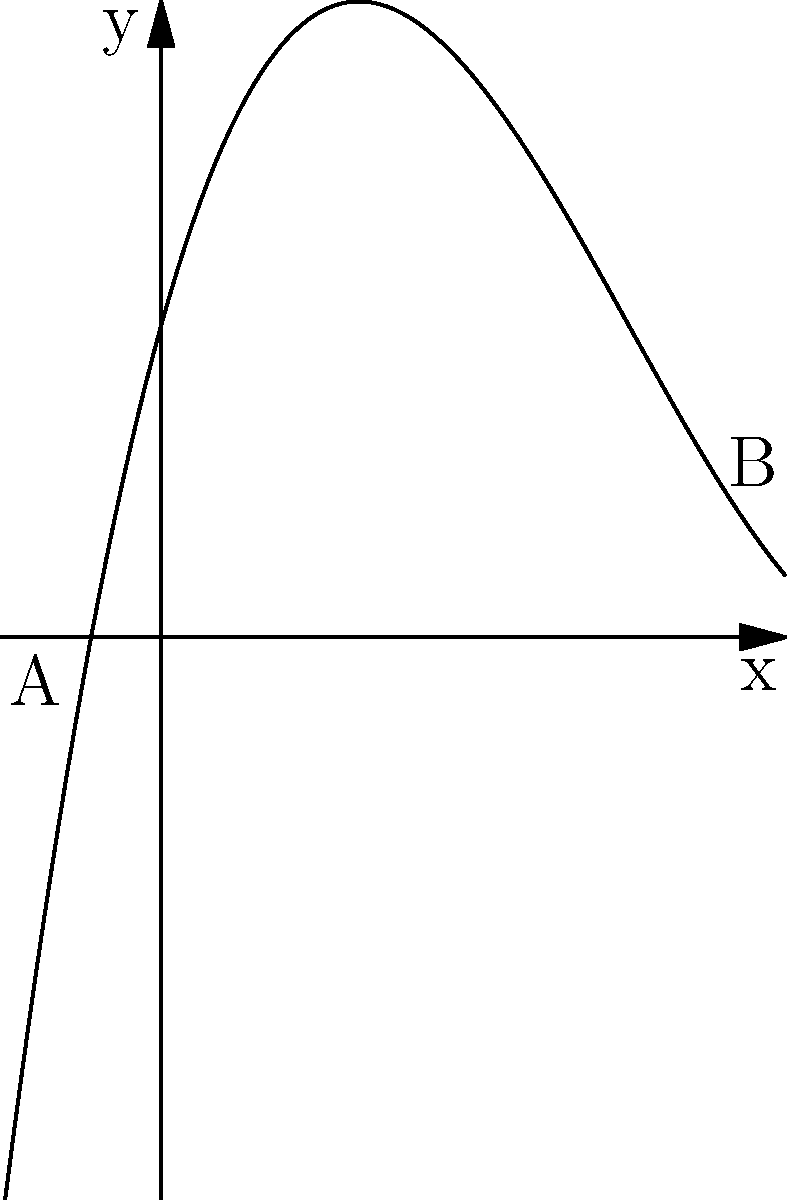As a costume designer for a period drama, you need to create a skirt with a specific silhouette. The director wants the skirt's outline to follow a polynomial function. The curve shown represents the side view of the skirt, where the x-axis is the horizontal distance from the waist, and the y-axis is the vertical distance from the ground. The function is given by $f(x) = 0.2x^3 - 1.8x^2 + 3.6x + 2$. What is the total change in height of the skirt from point A to point B? To find the change in height from point A to point B, we need to:

1. Identify the x-coordinates of points A and B:
   Point A: $x = -0.5$
   Point B: $x = 3.5$

2. Calculate the y-coordinates (heights) at these points using the given function:
   $f(x) = 0.2x^3 - 1.8x^2 + 3.6x + 2$

   For point A:
   $f(-0.5) = 0.2(-0.5)^3 - 1.8(-0.5)^2 + 3.6(-0.5) + 2$
   $= -0.025 - 0.45 - 1.8 + 2 = -0.275$

   For point B:
   $f(3.5) = 0.2(3.5)^3 - 1.8(3.5)^2 + 3.6(3.5) + 2$
   $= 8.575 - 22.05 + 12.6 + 2 = 1.125$

3. Calculate the difference in height:
   Change in height = $f(3.5) - f(-0.5) = 1.125 - (-0.275) = 1.4$

Therefore, the total change in height of the skirt from point A to point B is 1.4 units.
Answer: 1.4 units 